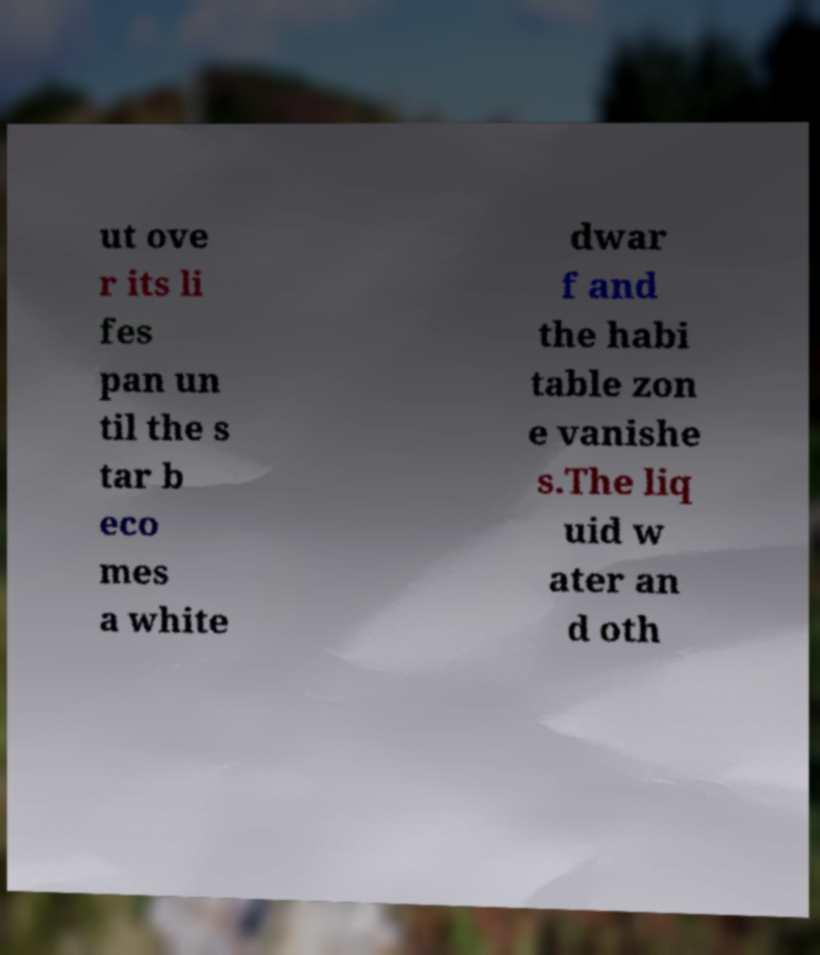For documentation purposes, I need the text within this image transcribed. Could you provide that? ut ove r its li fes pan un til the s tar b eco mes a white dwar f and the habi table zon e vanishe s.The liq uid w ater an d oth 